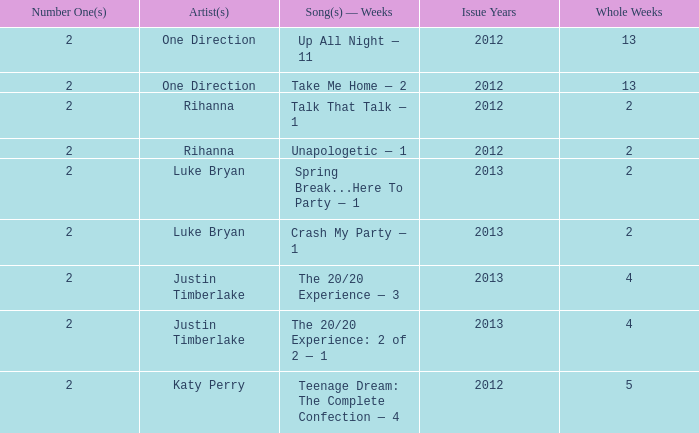What is the title of every song, and how many weeks was each song at #1 for One Direction? Up All Night — 11, Take Me Home — 2. 